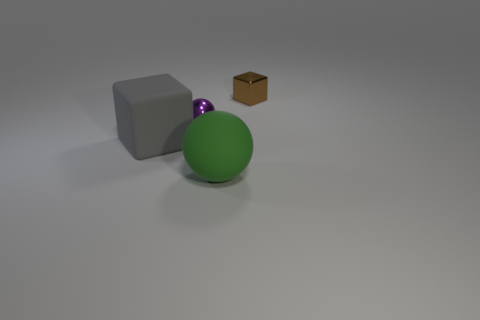Could you describe the contrast between the textures of the objects? Certainly, the scene presents a distinct contrast in textures. The matte grey block has a consistent, smooth texture that diffuses light softly. The large green ball's surface is slightly reflective with a subtle shine, indicative of a smooth material. The small purple ball has a metallic glint, suggesting a polished texture. Lastly, the brown cube's texture is grainy and coarse, possibly similar to cardboard or wood, which absorbs light rather than reflecting it. 